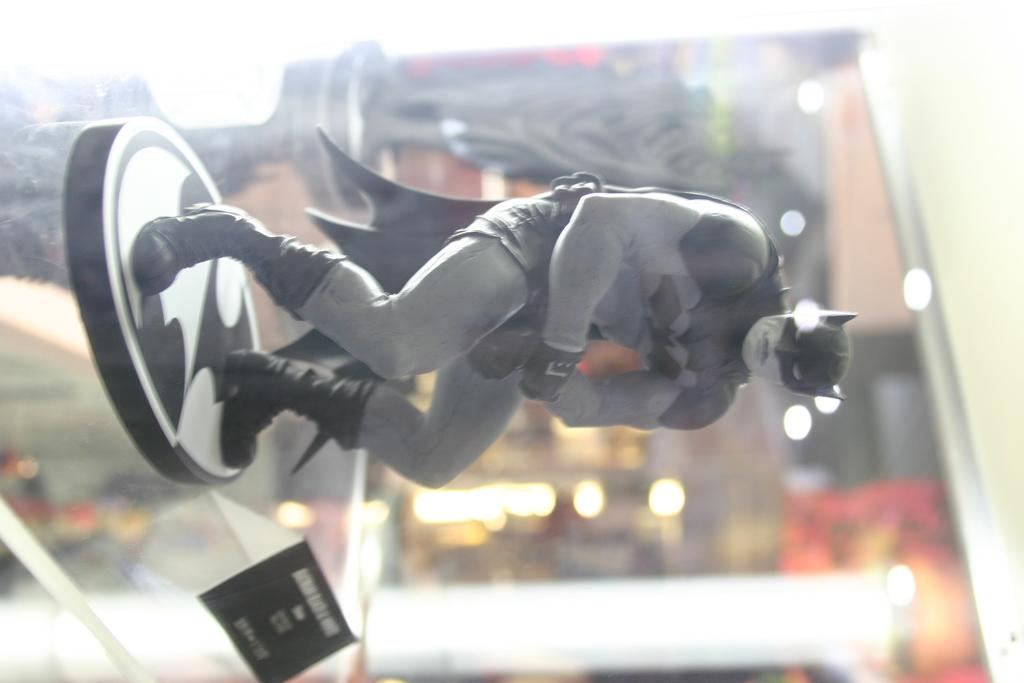What type of toy is in the image? There is a toy Batman in the image. What colors is the toy Batman in? The toy Batman is in ash and black color. Where is the toy Batman located in the image? The toy Batman is on a glass rack. What other object can be seen in the image? There is a black color board in the image. How would you describe the background of the image? The background of the image is blurred. What is the reaction of the toy Batman when someone sneezes in the image? There is no indication of a sneeze or a reaction from the toy Batman in the image. 